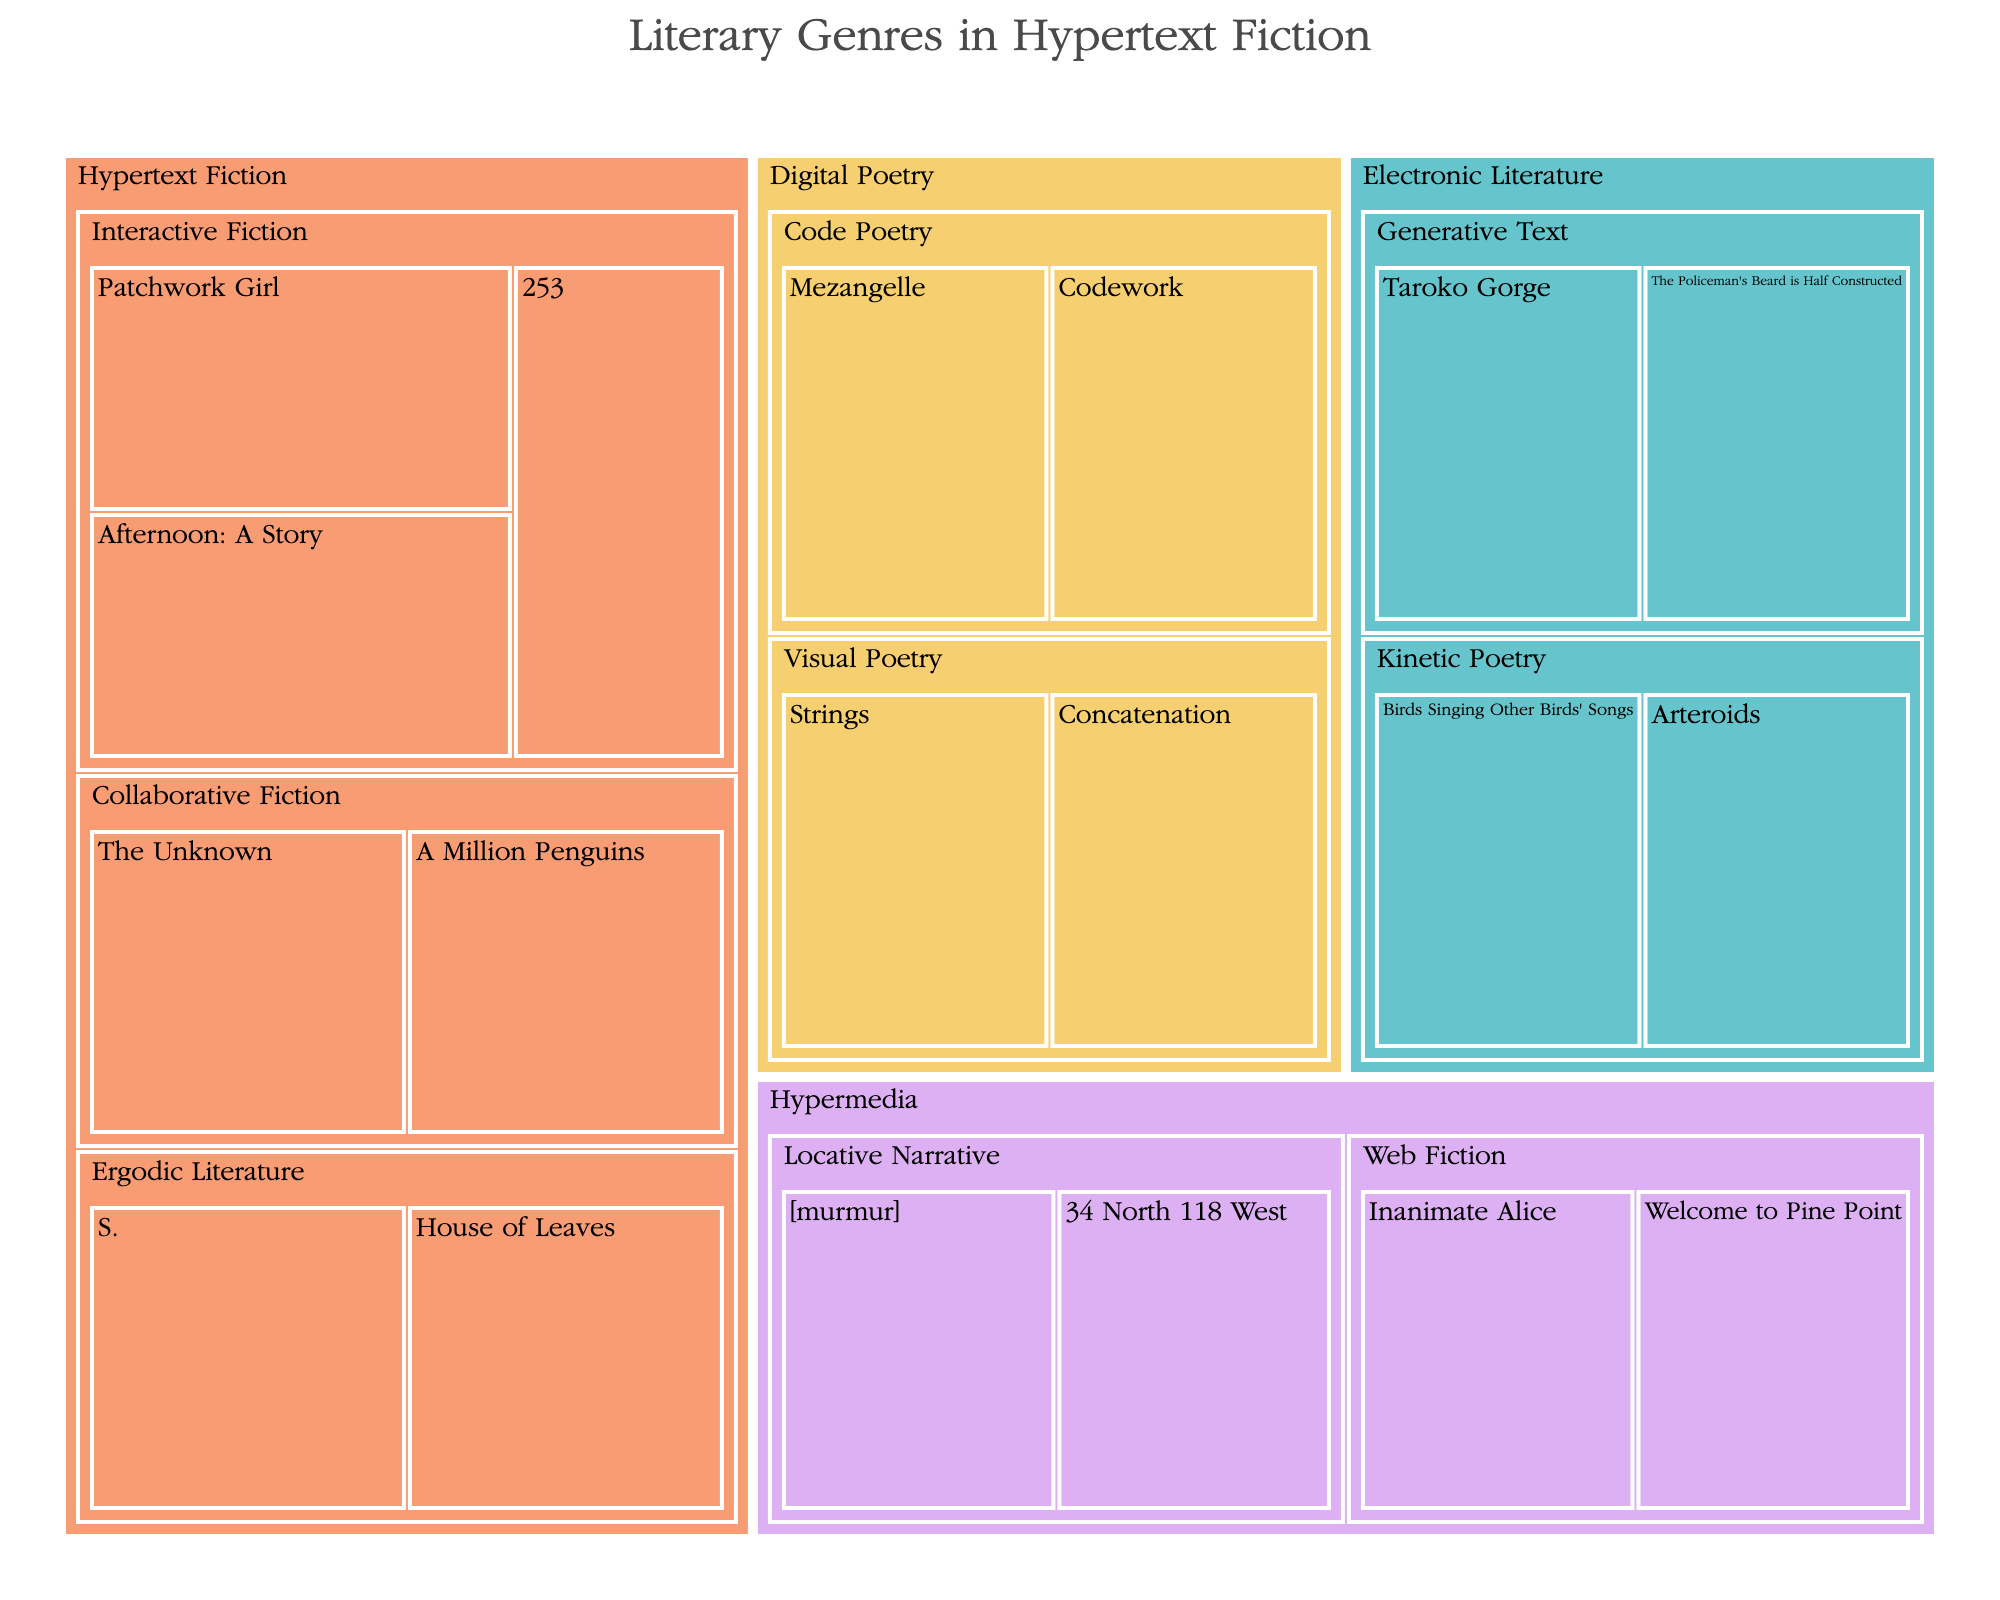How many main genres of literary works are represented in the treemap? There are four main genre labels in the treemap: Hypertext Fiction, Electronic Literature, Digital Poetry, and Hypermedia.
Answer: 4 Which genre has the most subgenres? By visually inspecting the treemap, Hypertext Fiction has the most subgenres with three: Interactive Fiction, Collaborative Fiction, and Ergodic Literature.
Answer: Hypertext Fiction Name all the works under the subgenre 'Interactive Fiction.' The treemap visually displays the works under 'Interactive Fiction' which are Afternoon: A Story, Patchwork Girl, and 253.
Answer: Afternoon: A Story, Patchwork Girl, 253 Which subgenres are part of the 'Hypermedia' genre? By examining the labels within the Hypermedia section, the subgenres 'Web Fiction' and 'Locative Narrative' are included.
Answer: Web Fiction, Locative Narrative Compare the number of works in 'Kinetic Poetry' and 'Code Poetry.' Which subgenre has more works? By counting the number of works in each subgenre within the Digital Poetry genre, 'Kinetic Poetry' has two works (Arteroids, Birds Singing Other Birds' Songs) and 'Code Poetry' also has two works (Mezangelle, Codework).
Answer: They have the same number of works What is the title and subgenre of the work that appears after 'House of Leaves' in the list of 'Ergodic Literature'? Referring to the treemap's visual structure within 'Ergodic Literature', the work following 'House of Leaves' is 'S.'
Answer: S., Ergodic Literature How many works are grouped under the 'Generative Text' subgenre? By checking the labels within the subgenre 'Generative Text' under Electronic Literature, there are two works: The Policeman's Beard is Half Constructed and Taroko Gorge.
Answer: 2 What is the largest section of the treemap that falls under Digital Poetry? By visually assessing the areas within the Digital Poetry genre, the subgenres 'Visual Poetry' and 'Code Poetry' both have equal size.
Answer: Visual Poetry, Code Poetry Name one work under 'Visual Poetry.' Looking at the labels within the subgenre 'Visual Poetry' under Digital Poetry, one example is Concatenation.
Answer: Concatenation 